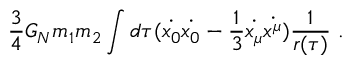<formula> <loc_0><loc_0><loc_500><loc_500>{ \frac { 3 } { 4 } } G _ { N } m _ { 1 } m _ { 2 } \int d \tau ( \dot { x _ { 0 } } \dot { x _ { 0 } } - { \frac { 1 } { 3 } } \dot { x _ { \mu } } \dot { x ^ { \mu } } ) { \frac { 1 } { r ( \tau ) } } .</formula> 